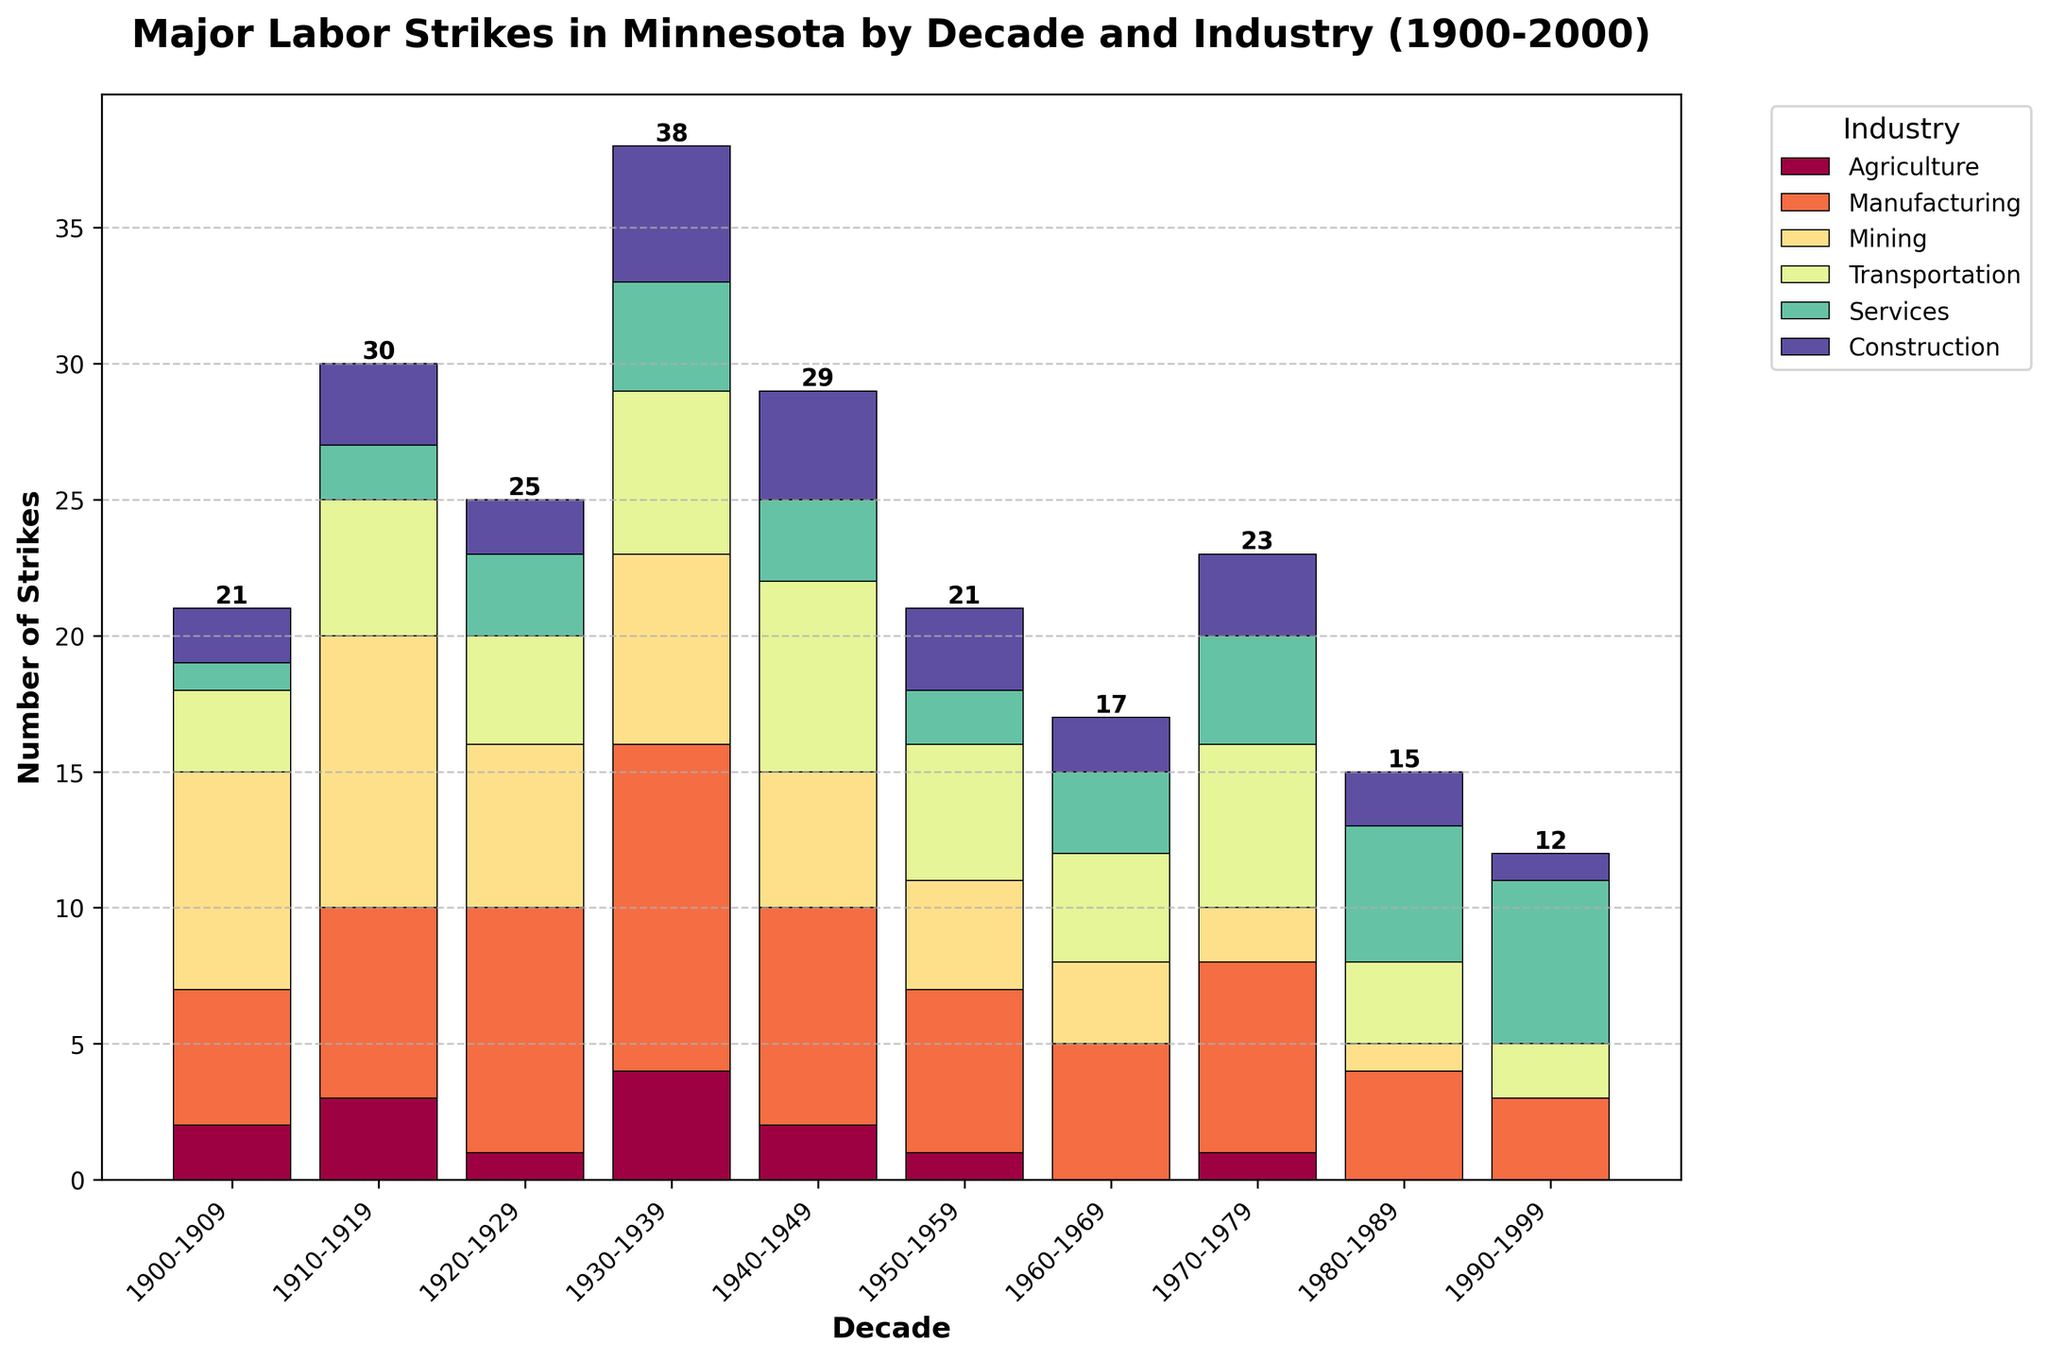Which decade had the highest total number of labor strikes? Sum up the number of strikes from all industries for each decade. The decade with the highest sum is 1930-1939, with a total of 38 strikes (4+12+7+6+4+5=38).
Answer: 1930-1939 Which industry experienced the most strikes during the 1940-1949 decade? Look at the bars representing the 1940-1949 decade and find the industry with the tallest bar. Manufacturing had 8 strikes, which is the highest among all industries for that decade.
Answer: Manufacturing How does the total number of strikes in the 1900-1909 decade compare to the 1950-1959 decade? Sum up the strikes for both decades: For 1900-1909, the total is 21 (2+5+8+3+1+2). For 1950-1959, the total is 21 (1+6+4+5+2+3). Both decades had the same total number of strikes.
Answer: Equal What is the trend in the number of strikes in the Services industry from the 1900s to the 1990s? Observe the height of the bars representing the Services industry for each decade. The number of strikes in the Services industry generally increases over time, with a small fluctuation in the middle decades.
Answer: Increasing In which decade did the Agriculture industry experience the fewest strikes? Look at the heights of the bars representing the Agriculture industry across decades. The 1960-1969, 1980-1989, and 1990-1999 decades all had zero strikes in Agriculture.
Answer: 1960-1969, 1980-1989, 1990-1999 Which industry had the steepest decline in the number of strikes from the 1930-1939 decade to the 1940-1949 decade? Calculate the difference in the number of strikes for each industry between the two decades. Mining went from 7 strikes in 1930-1939 to 5 strikes in 1940-1949, a decline of 2, which is the largest decline among the industries.
Answer: Mining What is the average number of strikes per decade in the Manufacturing industry? Sum up the number of strikes for each decade in the Manufacturing industry: 5+7+9+12+8+6+5+7+4+3 = 66. Since there are 10 decades, divide the sum by 10. The average is 66/10 = 6.6.
Answer: 6.6 In the decade with the second-highest number of total strikes, which industry had the highest number of strikes? Identify the decade with the second-highest total strikes, which is 1910-1919 with a total of 30 strikes. Then, find the industry with the highest number of strikes in this decade, which is Mining with 10 strikes.
Answer: Mining Which decade and industry combination had the lowest number of strikes? Identify the bars with the shortest height across decades and industries. The Services industry in the 1900-1909 decade had only 1 strike, which is the lowest number.
Answer: Services in 1900-1909 What is the combined total number of strikes in the Construction and Transportation industries for the 1930-1939 decade? Sum up the number of strikes in the Construction (5) and Transportation (6) industries for the 1930-1939 decade. The combined total is 5 + 6 = 11.
Answer: 11 